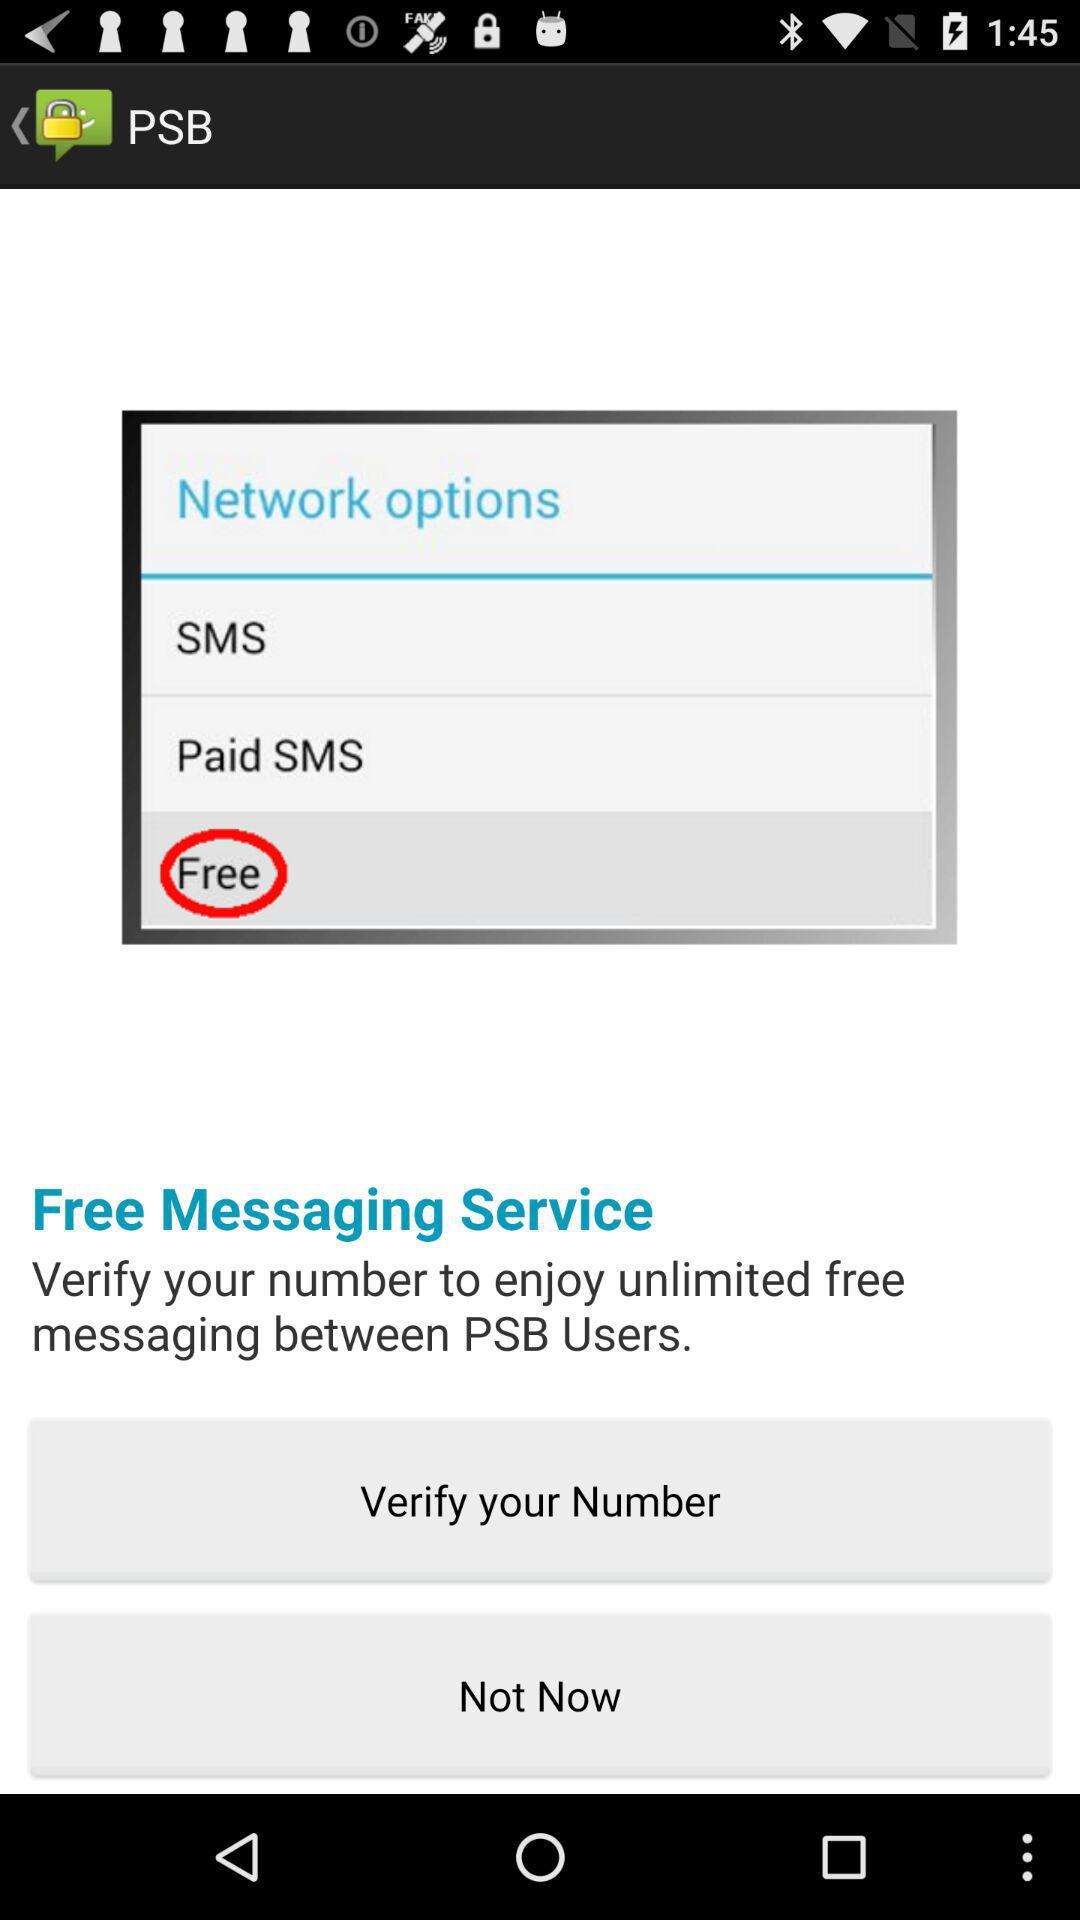What is the application name? The application name is "PSB". 